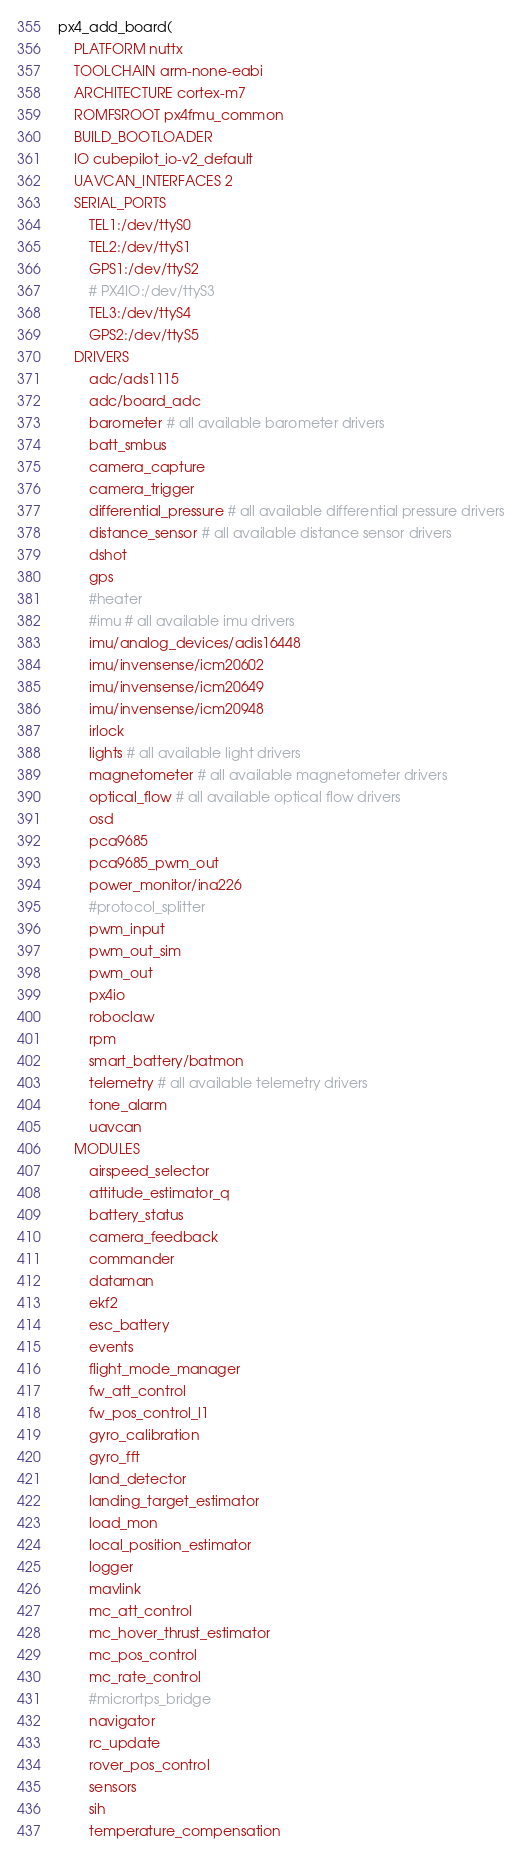Convert code to text. <code><loc_0><loc_0><loc_500><loc_500><_CMake_>
px4_add_board(
	PLATFORM nuttx
	TOOLCHAIN arm-none-eabi
	ARCHITECTURE cortex-m7
	ROMFSROOT px4fmu_common
	BUILD_BOOTLOADER
	IO cubepilot_io-v2_default
	UAVCAN_INTERFACES 2
	SERIAL_PORTS
		TEL1:/dev/ttyS0
		TEL2:/dev/ttyS1
		GPS1:/dev/ttyS2
		# PX4IO:/dev/ttyS3
		TEL3:/dev/ttyS4
		GPS2:/dev/ttyS5
	DRIVERS
		adc/ads1115
		adc/board_adc
		barometer # all available barometer drivers
		batt_smbus
		camera_capture
		camera_trigger
		differential_pressure # all available differential pressure drivers
		distance_sensor # all available distance sensor drivers
		dshot
		gps
		#heater
		#imu # all available imu drivers
		imu/analog_devices/adis16448
		imu/invensense/icm20602
		imu/invensense/icm20649
		imu/invensense/icm20948
		irlock
		lights # all available light drivers
		magnetometer # all available magnetometer drivers
		optical_flow # all available optical flow drivers
		osd
		pca9685
		pca9685_pwm_out
		power_monitor/ina226
		#protocol_splitter
		pwm_input
		pwm_out_sim
		pwm_out
		px4io
		roboclaw
		rpm
		smart_battery/batmon
		telemetry # all available telemetry drivers
		tone_alarm
		uavcan
	MODULES
		airspeed_selector
		attitude_estimator_q
		battery_status
		camera_feedback
		commander
		dataman
		ekf2
		esc_battery
		events
		flight_mode_manager
		fw_att_control
		fw_pos_control_l1
		gyro_calibration
		gyro_fft
		land_detector
		landing_target_estimator
		load_mon
		local_position_estimator
		logger
		mavlink
		mc_att_control
		mc_hover_thrust_estimator
		mc_pos_control
		mc_rate_control
		#micrortps_bridge
		navigator
		rc_update
		rover_pos_control
		sensors
		sih
		temperature_compensation</code> 